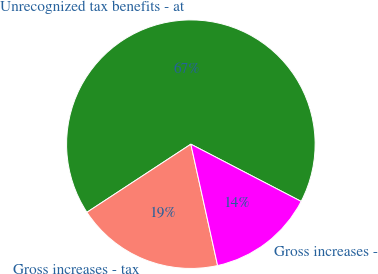Convert chart to OTSL. <chart><loc_0><loc_0><loc_500><loc_500><pie_chart><fcel>Unrecognized tax benefits - at<fcel>Gross increases - tax<fcel>Gross increases -<nl><fcel>66.85%<fcel>19.22%<fcel>13.93%<nl></chart> 